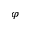<formula> <loc_0><loc_0><loc_500><loc_500>\varphi</formula> 